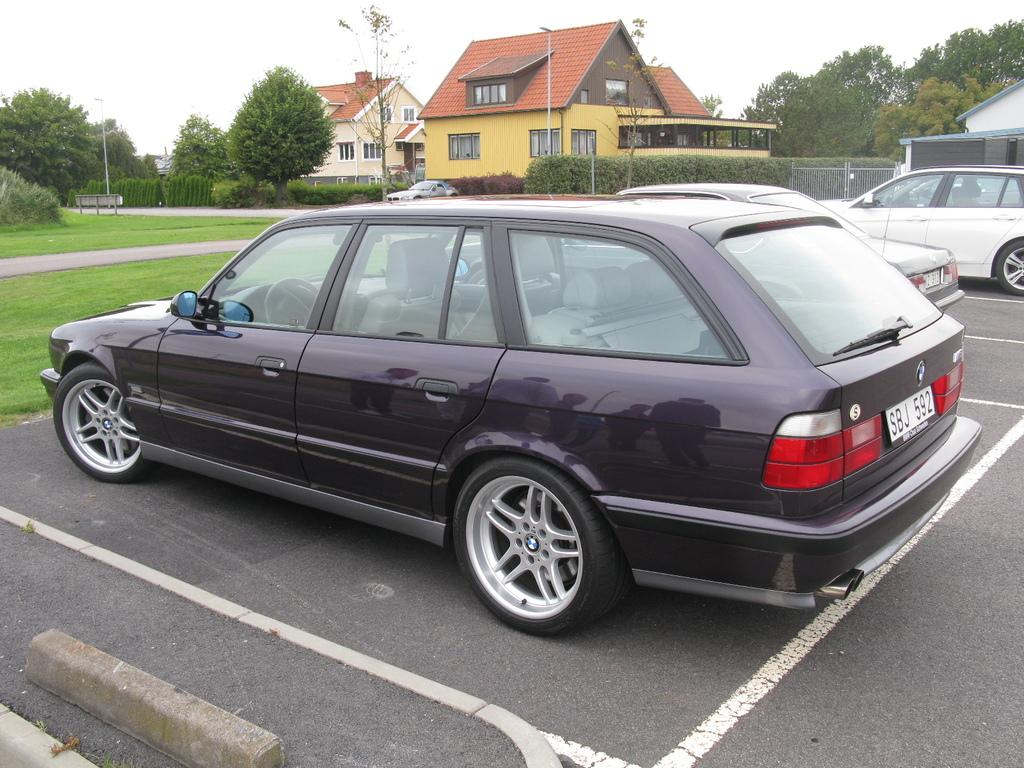What can be seen on the road in the image? There are vehicles on the road in the image. What type of natural elements are visible in the background of the image? There are trees, hedges, and a fence in the background of the image. What type of structures can be seen in the background of the image? There are houses and a board in the background of the image. What is visible at the top of the image? The sky is visible at the top of the image. Can you tell me how many giraffes are standing near the houses in the image? There are no giraffes present in the image; it features vehicles on the road and various structures and natural elements in the background. What type of clothing is the servant wearing in the image? There is no servant present in the image. 